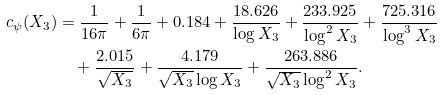<formula> <loc_0><loc_0><loc_500><loc_500>c _ { \psi } ( X _ { 3 } ) & = \frac { 1 } { 1 6 \pi } + \frac { 1 } { 6 \pi } + 0 . 1 8 4 + \frac { 1 8 . 6 2 6 } { \log X _ { 3 } } + \frac { 2 3 3 . 9 2 5 } { \log ^ { 2 } X _ { 3 } } + \frac { 7 2 5 . 3 1 6 } { \log ^ { 3 } X _ { 3 } } \\ & \quad + \frac { 2 . 0 1 5 } { \sqrt { X _ { 3 } } } + \frac { 4 . 1 7 9 } { \sqrt { X _ { 3 } } \log X _ { 3 } } + \frac { 2 6 3 . 8 8 6 } { \sqrt { X _ { 3 } } \log ^ { 2 } X _ { 3 } } .</formula> 